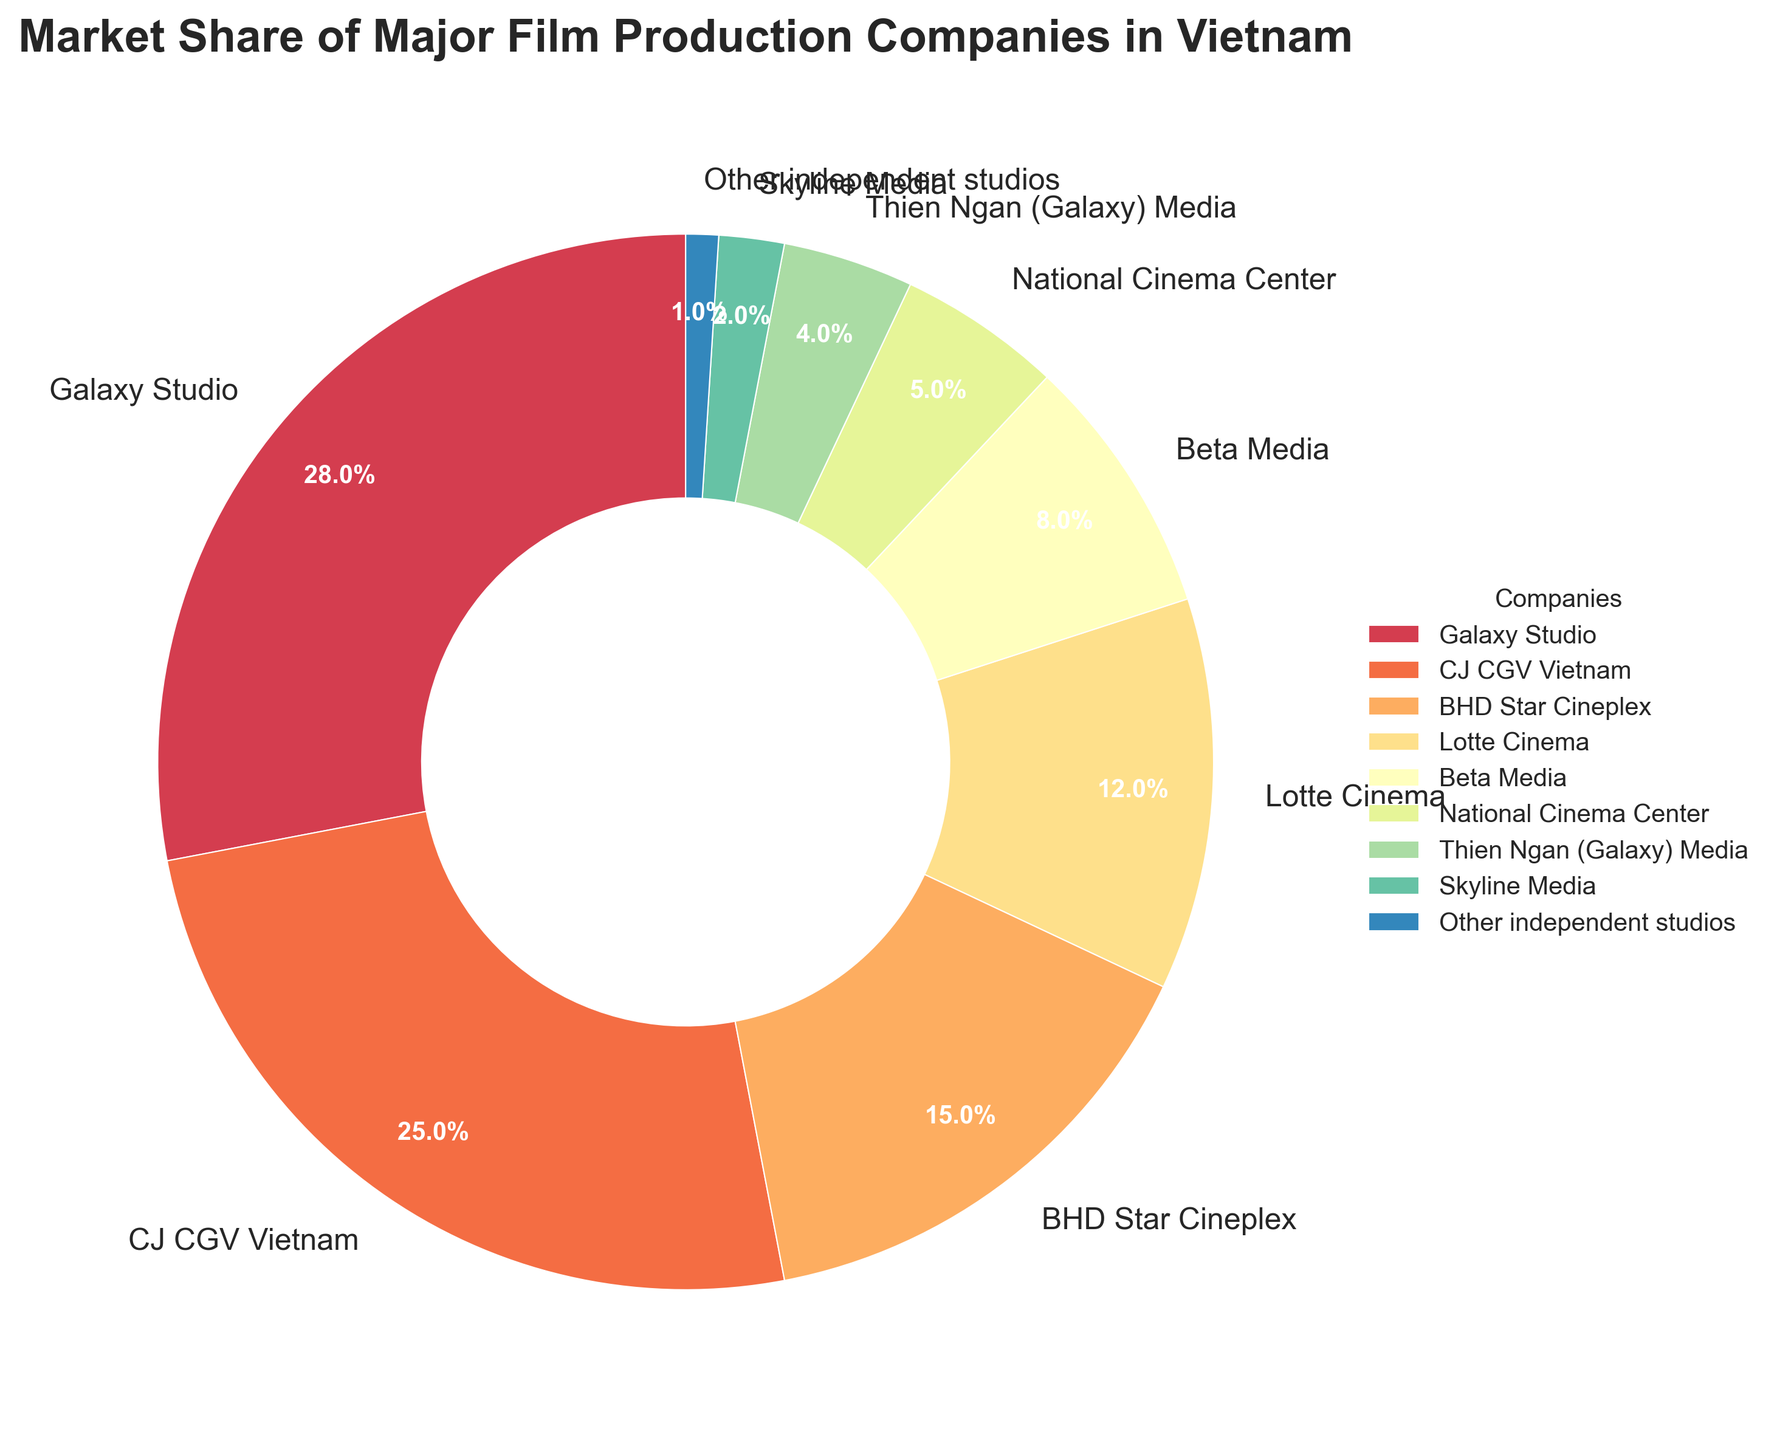What is the market share of the company with the highest share? Galaxy Studio has the highest market share. By looking at the pie chart, we see that Galaxy Studio holds 28% of the market share, as indicated by the largest wedge.
Answer: 28% How much larger is Galaxy Studio's market share compared to CJ CGV Vietnam's? Galaxy Studio has a market share of 28%, and CJ CGV Vietnam has a market share of 25%. The difference can be calculated as 28% - 25% = 3%.
Answer: 3% Which companies have a market share smaller than 10%? By observing the pie chart, we see that Beta Media, National Cinema Center, Thien Ngan (Galaxy) Media, Skyline Media, and Other independent studios all have market shares less than 10%.
Answer: Beta Media, National Cinema Center, Thien Ngan (Galaxy) Media, Skyline Media, Other independent studios What are the combined market shares of BHD Star Cineplex and Lotte Cinema? BHD Star Cineplex has 15%, and Lotte Cinema has 12%. Adding these together gives 15% + 12% = 27%.
Answer: 27% What fraction of the market is held by the companies other than the top three? The top three companies are Galaxy Studio (28%), CJ CGV Vietnam (25%), and BHD Star Cineplex (15%). Adding these gives a combined share of 28% + 25% + 15% = 68%. Therefore, the market share of the other companies is 100% - 68% = 32%.
Answer: 32% Which company has the smallest market share, and what is it? By looking at the pie chart, Skyline Media has the smallest market share at 2%, indicated by the smallest wedge.
Answer: Skyline Media, 2% How does the market share of Thien Ngan (Galaxy) Media compare to the combination of Other independent studios and Skyline Media? Thien Ngan (Galaxy) Media has a market share of 4%. Other independent studios have 1%, and Skyline Media has 2%. Together, they sum up to 1% + 2% = 3%. So, Thien Ngan (Galaxy) Media has a larger market share compared to the combination.
Answer: Larger What is the average market share of all the listed companies? To find the average, sum all the market shares and then divide by the number of companies. The sum is 28 + 25 + 15 + 12 + 8 + 5 + 4 + 2 + 1 = 100. Dividing by the number of companies, 100 / 9 ≈ 11.1.
Answer: ≈ 11.1% Which two companies combined have a market share closest to the market share of Galaxy Studio? Galaxy Studio has a market share of 28%. CJ CGV Vietnam has 25%, and adding any other company would exceed 28%. The two closest combined shares are BHD Star Cineplex with 15% and Lotte Cinema with 12%. Together, 15% + 12% = 27%, which is the closest.
Answer: BHD Star Cineplex and Lotte Cinema 